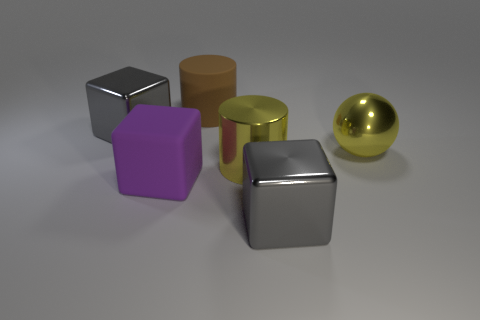Add 1 rubber cylinders. How many objects exist? 7 Subtract all cylinders. How many objects are left? 4 Add 4 big purple rubber things. How many big purple rubber things exist? 5 Subtract 0 green spheres. How many objects are left? 6 Subtract all big gray cubes. Subtract all rubber cylinders. How many objects are left? 3 Add 2 metal blocks. How many metal blocks are left? 4 